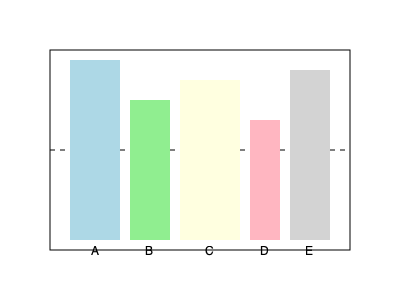Based on the blogger's recommended organization of athletic gear, you're arranging equipment on a rack. The diagram shows 5 pieces of gear (A, B, C, D, E) placed on the rack. If the middle shelf is represented by the dotted line, what is the ratio of the total height of equipment above the middle shelf to the total height of equipment below it? Let's approach this step-by-step:

1. First, we need to determine the height of each piece of equipment above and below the middle shelf.

2. For equipment A:
   Above: $\frac{9}{18} = 0.5$ of total height
   Below: $\frac{9}{18} = 0.5$ of total height

3. For equipment B:
   Above: $\frac{5}{14} = 0.357$ of total height
   Below: $\frac{9}{14} = 0.643$ of total height

4. For equipment C:
   Above: $\frac{7}{16} = 0.4375$ of total height
   Below: $\frac{9}{16} = 0.5625$ of total height

5. For equipment D:
   Above: $\frac{3}{12} = 0.25$ of total height
   Below: $\frac{9}{12} = 0.75$ of total height

6. For equipment E:
   Above: $\frac{8}{17} = 0.471$ of total height
   Below: $\frac{9}{17} = 0.529$ of total height

7. Now, let's sum up the proportions:
   Total above: $0.5 + 0.357 + 0.4375 + 0.25 + 0.471 = 2.0155$
   Total below: $0.5 + 0.643 + 0.5625 + 0.75 + 0.529 = 2.9845$

8. The ratio of above to below is:
   $\frac{2.0155}{2.9845} \approx 0.6753$

9. This can be simplified to approximately $2:3$
Answer: 2:3 